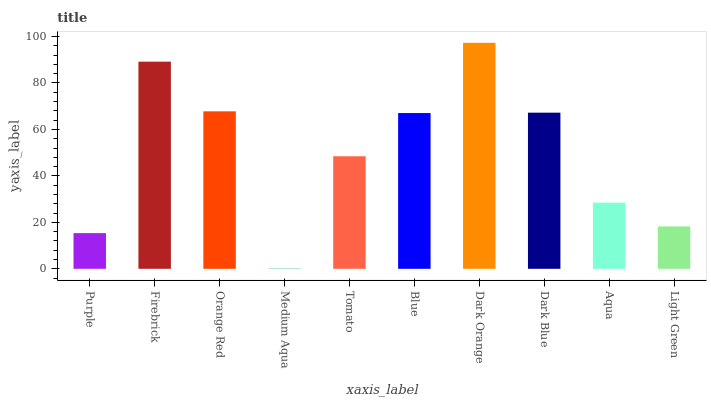Is Medium Aqua the minimum?
Answer yes or no. Yes. Is Dark Orange the maximum?
Answer yes or no. Yes. Is Firebrick the minimum?
Answer yes or no. No. Is Firebrick the maximum?
Answer yes or no. No. Is Firebrick greater than Purple?
Answer yes or no. Yes. Is Purple less than Firebrick?
Answer yes or no. Yes. Is Purple greater than Firebrick?
Answer yes or no. No. Is Firebrick less than Purple?
Answer yes or no. No. Is Blue the high median?
Answer yes or no. Yes. Is Tomato the low median?
Answer yes or no. Yes. Is Dark Blue the high median?
Answer yes or no. No. Is Blue the low median?
Answer yes or no. No. 